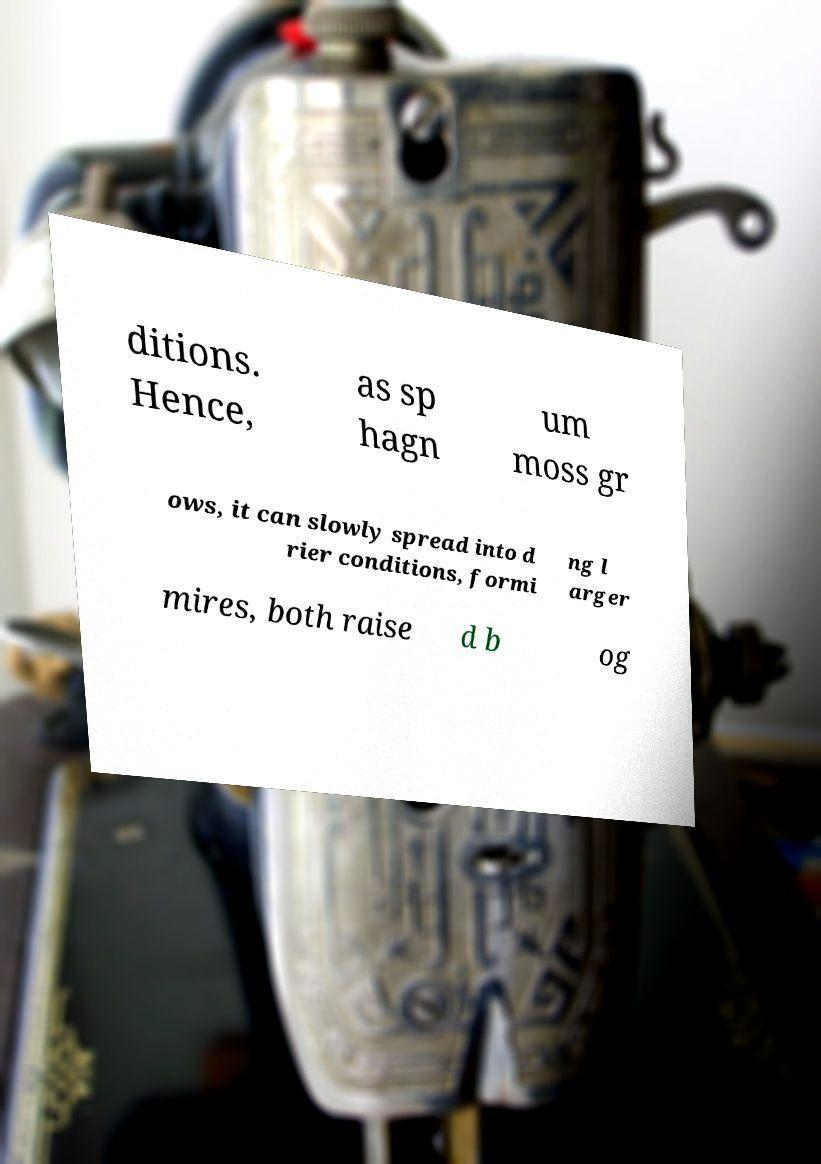Please read and relay the text visible in this image. What does it say? ditions. Hence, as sp hagn um moss gr ows, it can slowly spread into d rier conditions, formi ng l arger mires, both raise d b og 